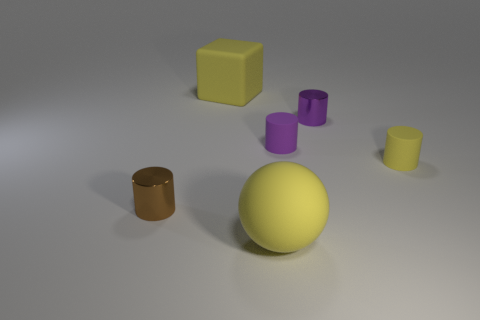Subtract all gray blocks. How many purple cylinders are left? 2 Subtract 1 cylinders. How many cylinders are left? 3 Add 1 small purple metallic cylinders. How many objects exist? 7 Subtract all green cylinders. Subtract all brown cubes. How many cylinders are left? 4 Add 6 small yellow objects. How many small yellow objects are left? 7 Add 3 cyan rubber balls. How many cyan rubber balls exist? 3 Subtract 1 yellow cubes. How many objects are left? 5 Subtract all cubes. How many objects are left? 5 Subtract all cylinders. Subtract all tiny purple metal cylinders. How many objects are left? 1 